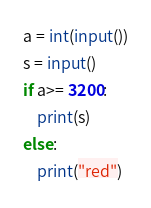Convert code to text. <code><loc_0><loc_0><loc_500><loc_500><_Python_>a = int(input())
s = input()
if a>= 3200:
    print(s)
else:
    print("red")</code> 